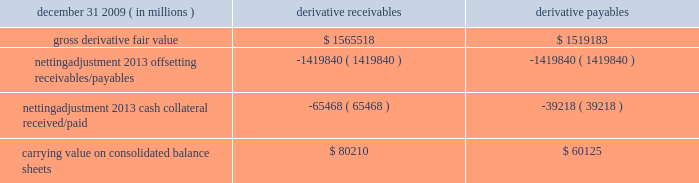Jpmorgan chase & co./2009 annual report 181 the table shows the current credit risk of derivative receivables after netting adjustments , and the current liquidity risk of derivative payables after netting adjustments , as of december 31 , 2009. .
In addition to the collateral amounts reflected in the table above , at december 31 , 2009 , the firm had received and posted liquid secu- rities collateral in the amount of $ 15.5 billion and $ 11.7 billion , respectively .
The firm also receives and delivers collateral at the initiation of derivative transactions , which is available as security against potential exposure that could arise should the fair value of the transactions move in the firm 2019s or client 2019s favor , respectively .
Furthermore , the firm and its counterparties hold collateral related to contracts that have a non-daily call frequency for collateral to be posted , and collateral that the firm or a counterparty has agreed to return but has not yet settled as of the reporting date .
At december 31 , 2009 , the firm had received $ 16.9 billion and delivered $ 5.8 billion of such additional collateral .
These amounts were not netted against the derivative receivables and payables in the table above , because , at an individual counterparty level , the collateral exceeded the fair value exposure at december 31 , 2009 .
Credit derivatives credit derivatives are financial instruments whose value is derived from the credit risk associated with the debt of a third-party issuer ( the reference entity ) and which allow one party ( the protection purchaser ) to transfer that risk to another party ( the protection seller ) .
Credit derivatives expose the protection purchaser to the creditworthiness of the protection seller , as the protection seller is required to make payments under the contract when the reference entity experiences a credit event , such as a bankruptcy , a failure to pay its obligation or a restructuring .
The seller of credit protection receives a premium for providing protection but has the risk that the underlying instrument referenced in the contract will be subject to a credit event .
The firm is both a purchaser and seller of protection in the credit derivatives market and uses these derivatives for two primary purposes .
First , in its capacity as a market-maker in the dealer/client business , the firm actively risk manages a portfolio of credit derivatives by purchasing and selling credit protection , pre- dominantly on corporate debt obligations , to meet the needs of customers .
As a seller of protection , the firm 2019s exposure to a given reference entity may be offset partially , or entirely , with a contract to purchase protection from another counterparty on the same or similar reference entity .
Second , the firm uses credit derivatives to mitigate credit risk associated with its overall derivative receivables and traditional commercial credit lending exposures ( loans and unfunded commitments ) as well as to manage its exposure to residential and commercial mortgages .
See note 3 on pages 156--- 173 of this annual report for further information on the firm 2019s mortgage-related exposures .
In accomplishing the above , the firm uses different types of credit derivatives .
Following is a summary of various types of credit derivatives .
Credit default swaps credit derivatives may reference the credit of either a single refer- ence entity ( 201csingle-name 201d ) or a broad-based index , as described further below .
The firm purchases and sells protection on both single- name and index-reference obligations .
Single-name cds and index cds contracts are both otc derivative contracts .
Single- name cds are used to manage the default risk of a single reference entity , while cds index are used to manage credit risk associated with the broader credit markets or credit market segments .
Like the s&p 500 and other market indices , a cds index is comprised of a portfolio of cds across many reference entities .
New series of cds indices are established approximately every six months with a new underlying portfolio of reference entities to reflect changes in the credit markets .
If one of the reference entities in the index experi- ences a credit event , then the reference entity that defaulted is removed from the index .
Cds can also be referenced against spe- cific portfolios of reference names or against customized exposure levels based on specific client demands : for example , to provide protection against the first $ 1 million of realized credit losses in a $ 10 million portfolio of exposure .
Such structures are commonly known as tranche cds .
For both single-name cds contracts and index cds , upon the occurrence of a credit event , under the terms of a cds contract neither party to the cds contract has recourse to the reference entity .
The protection purchaser has recourse to the protection seller for the difference between the face value of the cds contract and the fair value of the reference obligation at the time of settling the credit derivative contract , also known as the recovery value .
The protection purchaser does not need to hold the debt instrument of the underlying reference entity in order to receive amounts due under the cds contract when a credit event occurs .
Credit-linked notes a credit linked note ( 201ccln 201d ) is a funded credit derivative where the issuer of the cln purchases credit protection on a referenced entity from the note investor .
Under the contract , the investor pays the issuer par value of the note at the inception of the transaction , and in return , the issuer pays periodic payments to the investor , based on the credit risk of the referenced entity .
The issuer also repays the investor the par value of the note at maturity unless the reference entity experiences a specified credit event .
In that event , the issuer is not obligated to repay the par value of the note , but rather , the issuer pays the investor the difference between the par value of the note .
What is the netting adjustment of the additional collateral in 2009 , in millions of dollars? 
Rationale: its the difference between the collateral received and delivered .
Computations: (16.9 - 5.8)
Answer: 11.1. Jpmorgan chase & co./2009 annual report 181 the table shows the current credit risk of derivative receivables after netting adjustments , and the current liquidity risk of derivative payables after netting adjustments , as of december 31 , 2009. .
In addition to the collateral amounts reflected in the table above , at december 31 , 2009 , the firm had received and posted liquid secu- rities collateral in the amount of $ 15.5 billion and $ 11.7 billion , respectively .
The firm also receives and delivers collateral at the initiation of derivative transactions , which is available as security against potential exposure that could arise should the fair value of the transactions move in the firm 2019s or client 2019s favor , respectively .
Furthermore , the firm and its counterparties hold collateral related to contracts that have a non-daily call frequency for collateral to be posted , and collateral that the firm or a counterparty has agreed to return but has not yet settled as of the reporting date .
At december 31 , 2009 , the firm had received $ 16.9 billion and delivered $ 5.8 billion of such additional collateral .
These amounts were not netted against the derivative receivables and payables in the table above , because , at an individual counterparty level , the collateral exceeded the fair value exposure at december 31 , 2009 .
Credit derivatives credit derivatives are financial instruments whose value is derived from the credit risk associated with the debt of a third-party issuer ( the reference entity ) and which allow one party ( the protection purchaser ) to transfer that risk to another party ( the protection seller ) .
Credit derivatives expose the protection purchaser to the creditworthiness of the protection seller , as the protection seller is required to make payments under the contract when the reference entity experiences a credit event , such as a bankruptcy , a failure to pay its obligation or a restructuring .
The seller of credit protection receives a premium for providing protection but has the risk that the underlying instrument referenced in the contract will be subject to a credit event .
The firm is both a purchaser and seller of protection in the credit derivatives market and uses these derivatives for two primary purposes .
First , in its capacity as a market-maker in the dealer/client business , the firm actively risk manages a portfolio of credit derivatives by purchasing and selling credit protection , pre- dominantly on corporate debt obligations , to meet the needs of customers .
As a seller of protection , the firm 2019s exposure to a given reference entity may be offset partially , or entirely , with a contract to purchase protection from another counterparty on the same or similar reference entity .
Second , the firm uses credit derivatives to mitigate credit risk associated with its overall derivative receivables and traditional commercial credit lending exposures ( loans and unfunded commitments ) as well as to manage its exposure to residential and commercial mortgages .
See note 3 on pages 156--- 173 of this annual report for further information on the firm 2019s mortgage-related exposures .
In accomplishing the above , the firm uses different types of credit derivatives .
Following is a summary of various types of credit derivatives .
Credit default swaps credit derivatives may reference the credit of either a single refer- ence entity ( 201csingle-name 201d ) or a broad-based index , as described further below .
The firm purchases and sells protection on both single- name and index-reference obligations .
Single-name cds and index cds contracts are both otc derivative contracts .
Single- name cds are used to manage the default risk of a single reference entity , while cds index are used to manage credit risk associated with the broader credit markets or credit market segments .
Like the s&p 500 and other market indices , a cds index is comprised of a portfolio of cds across many reference entities .
New series of cds indices are established approximately every six months with a new underlying portfolio of reference entities to reflect changes in the credit markets .
If one of the reference entities in the index experi- ences a credit event , then the reference entity that defaulted is removed from the index .
Cds can also be referenced against spe- cific portfolios of reference names or against customized exposure levels based on specific client demands : for example , to provide protection against the first $ 1 million of realized credit losses in a $ 10 million portfolio of exposure .
Such structures are commonly known as tranche cds .
For both single-name cds contracts and index cds , upon the occurrence of a credit event , under the terms of a cds contract neither party to the cds contract has recourse to the reference entity .
The protection purchaser has recourse to the protection seller for the difference between the face value of the cds contract and the fair value of the reference obligation at the time of settling the credit derivative contract , also known as the recovery value .
The protection purchaser does not need to hold the debt instrument of the underlying reference entity in order to receive amounts due under the cds contract when a credit event occurs .
Credit-linked notes a credit linked note ( 201ccln 201d ) is a funded credit derivative where the issuer of the cln purchases credit protection on a referenced entity from the note investor .
Under the contract , the investor pays the issuer par value of the note at the inception of the transaction , and in return , the issuer pays periodic payments to the investor , based on the credit risk of the referenced entity .
The issuer also repays the investor the par value of the note at maturity unless the reference entity experiences a specified credit event .
In that event , the issuer is not obligated to repay the par value of the note , but rather , the issuer pays the investor the difference between the par value of the note .
At december 31 , 2009 , what was the ratio of the firm had received to the additional collateral .? 
Computations: (16.9 / 5.8)
Answer: 2.91379. 